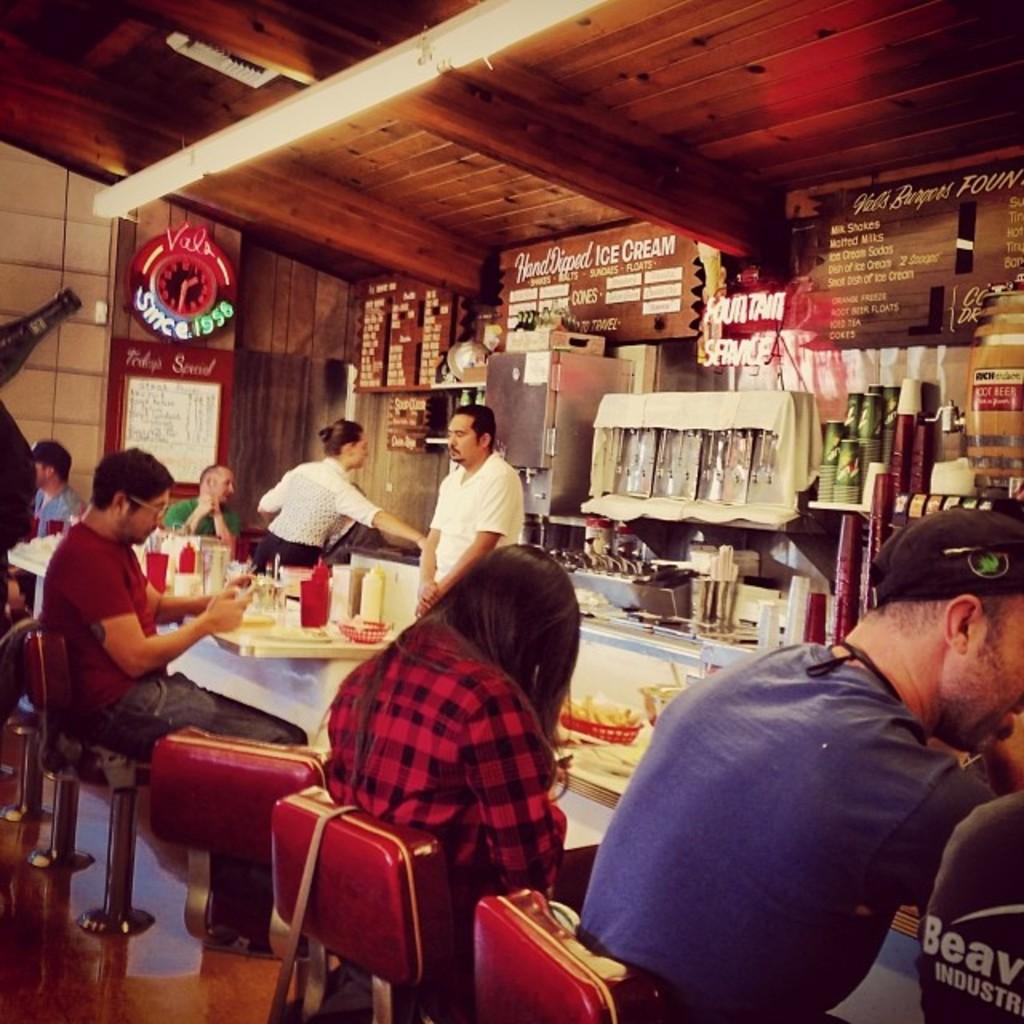How would you summarize this image in a sentence or two? This picture shows a food restaurant were few people seated on the chairs and we see few food items on the table. 